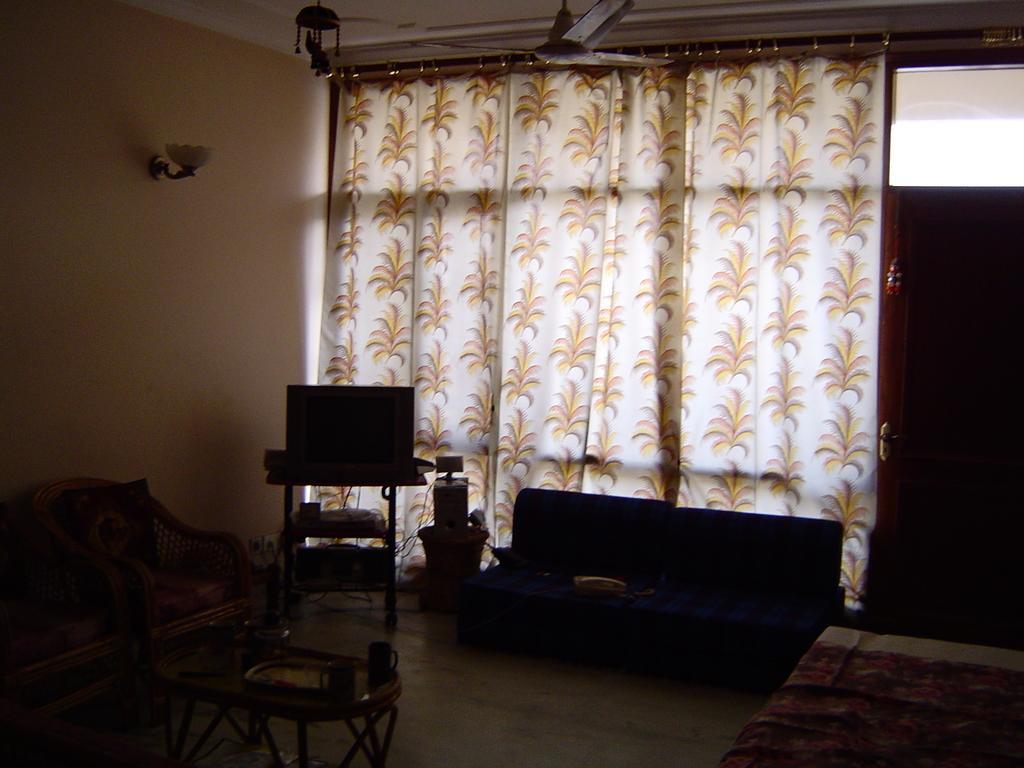Describe this image in one or two sentences. This picture shows few chairs and sofa and few curtains and a table with two cups on it. 